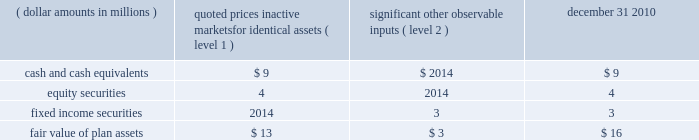1 2 4 n o t e s effective january 1 , 2011 , all u.s .
Employees , including u.s .
Legacy bgi employees , will participate in the brsp .
All plan assets in the two legacy bgi plans , including the 401k plan and retirement plan ( see below ) , were merged into the brsp on january 1 , 2011 .
Under the combined brsp , employee contributions of up to 8% ( 8 % ) of eligible compensation , as defined by the plan and subject to irc limitations , will be matched by the company at 50% ( 50 % ) .
In addition , the company will continue to make an annual retirement contribution to eligible participants equal to 3-5% ( 3-5 % ) of eligible compensation .
Blackrock institutional trust company 401 ( k ) savings plan ( formerly the bgi 401 ( k ) savings plan ) the company assumed a 401 ( k ) plan ( the 201cbgi plan 201d ) covering employees of former bgi as a result of the bgi transaction .
As part of the bgi plan , employee contributions for participants with at least one year of service were matched at 200% ( 200 % ) of participants 2019 pre-tax contributions up to 2% ( 2 % ) of base salary and overtime , and matched 100% ( 100 % ) of the next 2% ( 2 % ) of base salary and overtime , as defined by the plan and subject to irc limitations .
The maximum matching contribution a participant would have received is an amount equal to 6% ( 6 % ) of base salary up to the irc limitations .
The bgi plan expense was $ 12 million for the year ended december 31 , 2010 and immaterial to the company 2019s consolidated financial statements for the year ended december 31 , 2009 .
Effective january 1 , 2011 , the net assets of this plan merged into the brsp .
Blackrock institutional trust company retirement plan ( formerly the bgi retirement plan ) the company assumed a defined contribution money purchase pension plan ( 201cbgi retirement plan 201d ) as a result of the bgi transaction .
All salaried employees of former bgi and its participating affiliates who were u.s .
Residents on the u.s .
Payroll were eligible to participate .
For participants earning less than $ 100000 in base salary , the company contributed 6% ( 6 % ) of a participant 2019s total compensation ( base salary , overtime and performance bonus ) up to $ 100000 .
For participants earning $ 100000 or more in base salary , the company contributed 6% ( 6 % ) of a participant 2019s base salary and overtime up to the irc limita- tion of $ 245000 in 2010 .
These contributions were 25% ( 25 % ) vested once the participant has completed two years of service and then vested at a rate of 25% ( 25 % ) for each additional year of service completed .
Employees with five or more years of service under the retirement plan were 100% ( 100 % ) vested in their entire balance .
The retirement plan expense was $ 13 million for the year ended december 31 , 2010 and immaterial to the company 2019s consolidated financial statements for the year ended december 31 , 2009 .
Effective january 1 , 2011 , the net assets of this plan merged into the brsp .
Blackrock group personal pension plan blackrock investment management ( uk ) limited ( 201cbim 201d ) , a wholly-owned subsidiary of the company , contributes to the blackrock group personal pension plan , a defined contribution plan for all employees of bim .
Bim contributes between 6% ( 6 % ) and 15% ( 15 % ) of each employee 2019s eligible compensation .
The expense for this plan was $ 22 million , $ 13 million and $ 16 million for the years ended december 31 , 2010 , 2009 and 2008 , respectively .
Defined benefit plans in 2009 , prior to the bgi transaction , the company had several defined benefit pension plans in japan , germany , luxembourg and jersey .
All accrued benefits under these defined benefit plans are currently frozen and the plans are closed to new participants .
In 2008 , the defined benefit pension values in luxembourg were transferred into a new defined contribution plan for such employees , removing future liabilities .
Participant benefits under the plans will not change with salary increases or additional years of service .
Through the bgi transaction , the company assumed defined benefit pension plans in japan and germany which are closed to new participants .
During 2010 , these plans merged into the legacy blackrock plans in japan ( the 201cjapan plan 201d ) and germany .
At december 31 , 2010 and 2009 , the plan assets for these plans were approximately $ 19 million and $ 10 million , respectively , and the unfunded obligations were less than $ 6 million and $ 3 million , respectively , which were recorded in accrued compensation and benefits on the consolidated statements of financial condition .
Benefit payments for the next five years and in aggregate for the five years thereafter are not expected to be material .
Defined benefit plan assets for the japan plan of approximately $ 16 million are invested using a total return investment approach whereby a mix of equity securities , debt securities and other investments are used to preserve asset values , diversify risk and achieve the target investment return benchmark .
Investment strategies and asset allocations are based on consideration of plan liabilities and the funded status of the plan .
Investment performance and asset allocation are measured and monitored on an ongoing basis .
The current target allocations for the plan assets are 45-50% ( 45-50 % ) for u.s .
And international equity securities , 50-55% ( 50-55 % ) for u.s .
And international fixed income securities and 0-5% ( 0-5 % ) for cash and cash equivalents .
The table below provides the fair value of the defined benefit japan plan assets at december 31 , 2010 by asset category .
The table also identifies the level of inputs used to determine the fair value of assets in each category .
Quoted prices significant in active other markets for observable identical assets inputs december 31 , ( dollar amounts in millions ) ( level 1 ) ( level 2 ) 2010 .
The assets and unfunded obligation for the defined benefit pension plan in germany and jersey were immaterial to the company 2019s consolidated financial statements at december 31 , 2010 .
Post-retirement benefit plans prior to the bgi transaction , the company had requirements to deliver post-retirement medical benefits to a closed population based in the united kingdom and through the bgi transaction , the company assumed a post-retirement benefit plan to a closed population of former bgi employees in the united kingdom .
For the years ended december 31 , 2010 , 2009 and 2008 , expenses and unfunded obligations for these benefits were immaterial to the company 2019s consolidated financial statements .
In addition , through the bgi transaction , the company assumed a requirement to deliver post-retirement medical benefits to a .
What is the percentage change in expenses related to personal pension plan from 2008 to 2009? 
Computations: ((13 - 16) / 16)
Answer: -0.1875. 